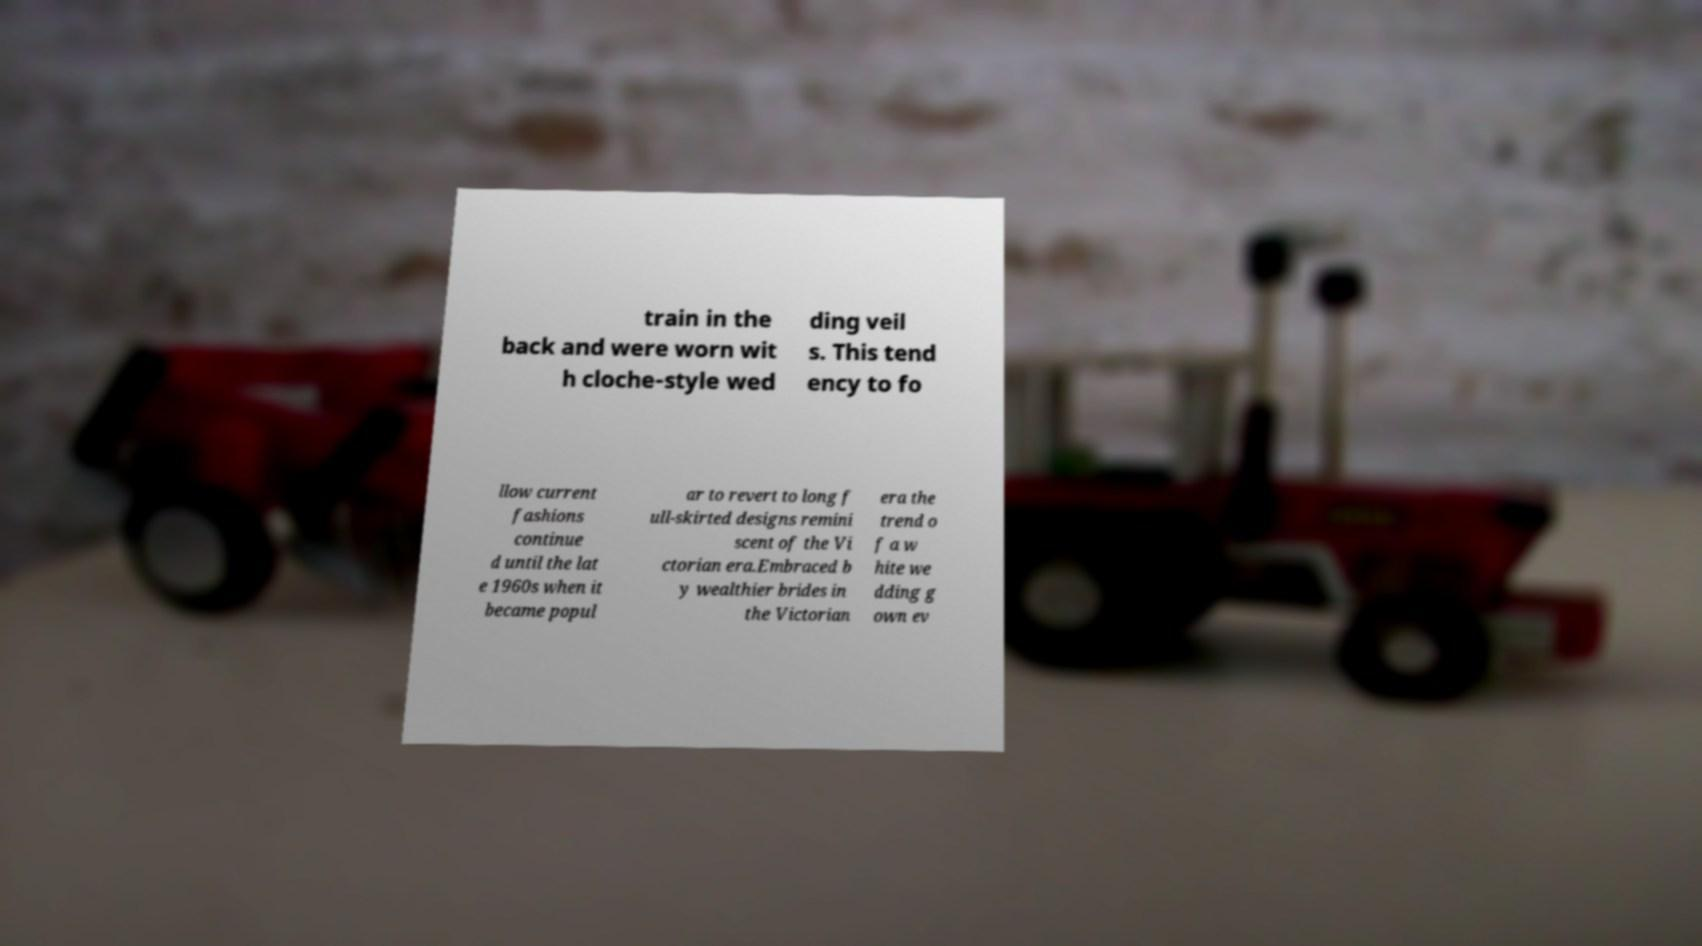Could you assist in decoding the text presented in this image and type it out clearly? train in the back and were worn wit h cloche-style wed ding veil s. This tend ency to fo llow current fashions continue d until the lat e 1960s when it became popul ar to revert to long f ull-skirted designs remini scent of the Vi ctorian era.Embraced b y wealthier brides in the Victorian era the trend o f a w hite we dding g own ev 